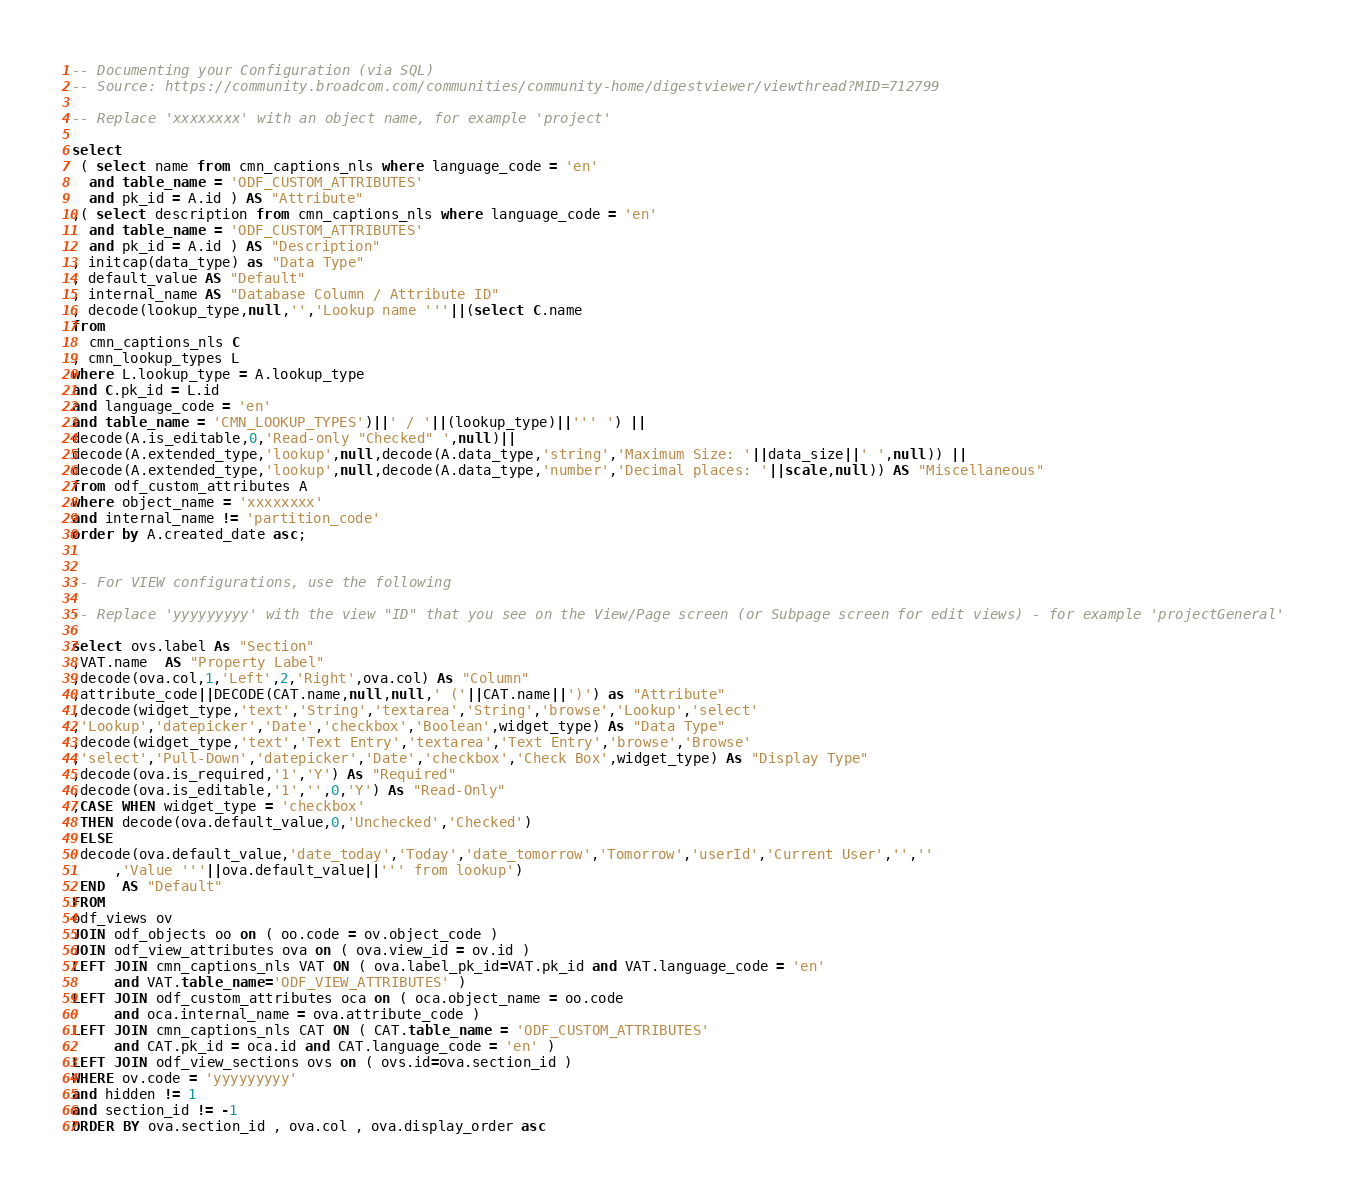Convert code to text. <code><loc_0><loc_0><loc_500><loc_500><_SQL_>-- Documenting your Configuration (via SQL)
-- Source: https://community.broadcom.com/communities/community-home/digestviewer/viewthread?MID=712799

-- Replace 'xxxxxxxx' with an object name, for example 'project'

select
 ( select name from cmn_captions_nls where language_code = 'en'
  and table_name = 'ODF_CUSTOM_ATTRIBUTES'
  and pk_id = A.id ) AS "Attribute"
,( select description from cmn_captions_nls where language_code = 'en'
  and table_name = 'ODF_CUSTOM_ATTRIBUTES'
  and pk_id = A.id ) AS "Description"
, initcap(data_type) as "Data Type"
, default_value AS "Default" 
, internal_name AS "Database Column / Attribute ID"
, decode(lookup_type,null,'','Lookup name '''||(select C.name
from
  cmn_captions_nls C
, cmn_lookup_types L
where L.lookup_type = A.lookup_type
and C.pk_id = L.id
and language_code = 'en'
and table_name = 'CMN_LOOKUP_TYPES')||' / '||(lookup_type)||''' ') ||
decode(A.is_editable,0,'Read-only "Checked" ',null)||
decode(A.extended_type,'lookup',null,decode(A.data_type,'string','Maximum Size: '||data_size||' ',null)) ||
decode(A.extended_type,'lookup',null,decode(A.data_type,'number','Decimal places: '||scale,null)) AS "Miscellaneous"
from odf_custom_attributes A
where object_name = 'xxxxxxxx'
and internal_name != 'partition_code'
order by A.created_date asc;


-- For VIEW configurations, use the following

-- Replace 'yyyyyyyyy' with the view "ID" that you see on the View/Page screen (or Subpage screen for edit views) - for example 'projectGeneral'

select ovs.label As "Section"
,VAT.name  AS "Property Label"
,decode(ova.col,1,'Left',2,'Right',ova.col) As "Column"
,attribute_code||DECODE(CAT.name,null,null,' ('||CAT.name||')') as "Attribute"
,decode(widget_type,'text','String','textarea','String','browse','Lookup','select'
,'Lookup','datepicker','Date','checkbox','Boolean',widget_type) As "Data Type"
,decode(widget_type,'text','Text Entry','textarea','Text Entry','browse','Browse'
,'select','Pull-Down','datepicker','Date','checkbox','Check Box',widget_type) As "Display Type"
,decode(ova.is_required,'1','Y') As "Required"
,decode(ova.is_editable,'1','',0,'Y') As "Read-Only"
,CASE WHEN widget_type = 'checkbox'
 THEN decode(ova.default_value,0,'Unchecked','Checked')
 ELSE
 decode(ova.default_value,'date_today','Today','date_tomorrow','Tomorrow','userId','Current User','',''
     ,'Value '''||ova.default_value||''' from lookup')
 END  AS "Default"
FROM
odf_views ov
JOIN odf_objects oo on ( oo.code = ov.object_code )
JOIN odf_view_attributes ova on ( ova.view_id = ov.id )
LEFT JOIN cmn_captions_nls VAT ON ( ova.label_pk_id=VAT.pk_id and VAT.language_code = 'en'
     and VAT.table_name='ODF_VIEW_ATTRIBUTES' )
LEFT JOIN odf_custom_attributes oca on ( oca.object_name = oo.code
     and oca.internal_name = ova.attribute_code )
LEFT JOIN cmn_captions_nls CAT ON ( CAT.table_name = 'ODF_CUSTOM_ATTRIBUTES' 
     and CAT.pk_id = oca.id and CAT.language_code = 'en' )   
LEFT JOIN odf_view_sections ovs on ( ovs.id=ova.section_id )
WHERE ov.code = 'yyyyyyyyy'
and hidden != 1
and section_id != -1
ORDER BY ova.section_id , ova.col , ova.display_order asc
</code> 